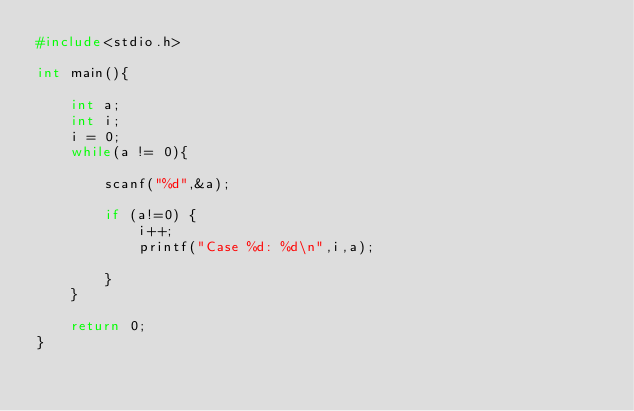<code> <loc_0><loc_0><loc_500><loc_500><_C_>#include<stdio.h>

int main(){
    
    int a;
    int i;
    i = 0;
    while(a != 0){
        
        scanf("%d",&a);
    
        if (a!=0) {
            i++;
            printf("Case %d: %d\n",i,a);
        
        }
    }
   
    return 0;
}</code> 